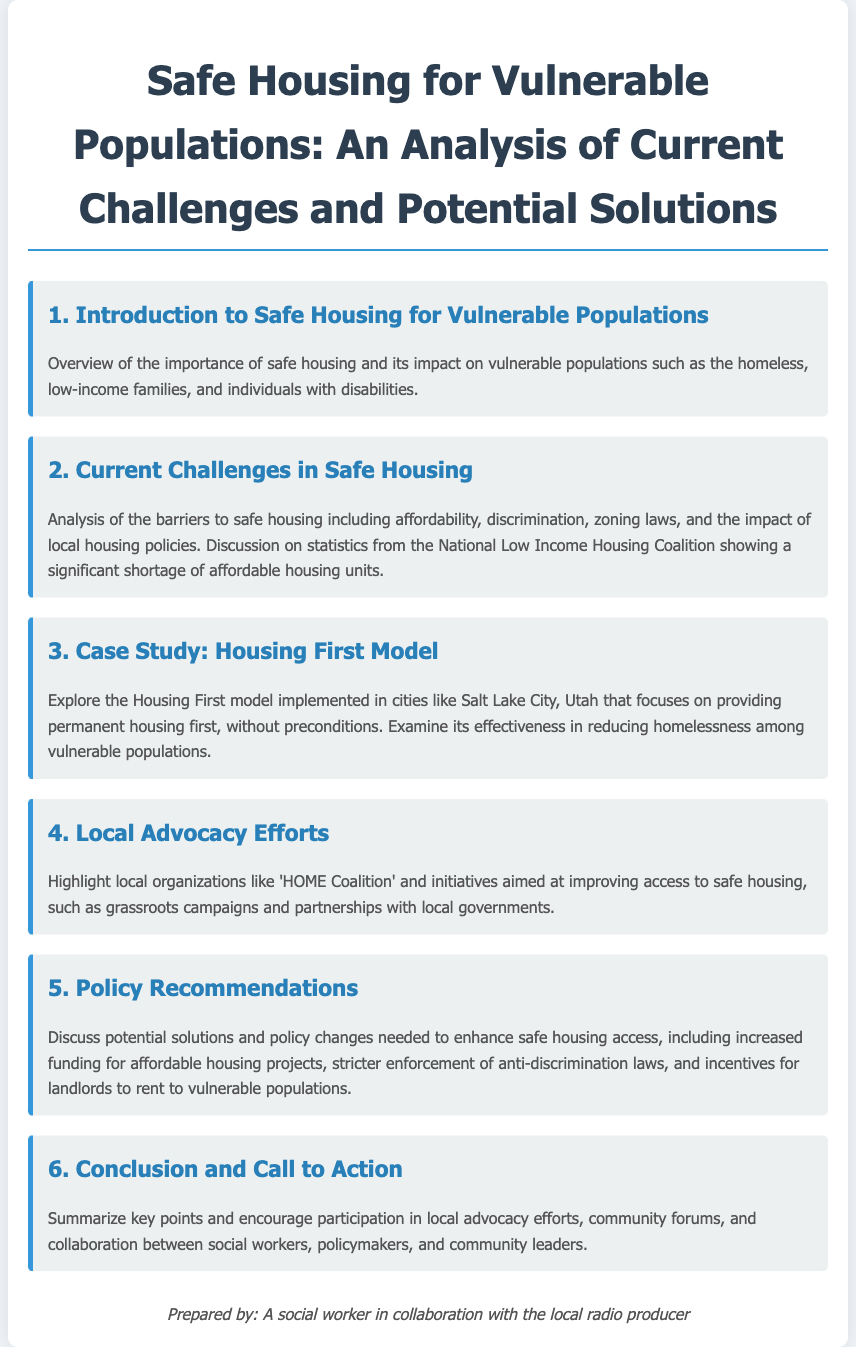What is the title of the agenda? The title of the agenda is featured prominently at the top of the document, clearly stating the focus of the analysis.
Answer: Safe Housing for Vulnerable Populations: An Analysis of Current Challenges and Potential Solutions What is the first agenda item? The first agenda item introduces the main topic and its importance, setting the stage for the discussion.
Answer: Introduction to Safe Housing for Vulnerable Populations What model is explored in the case study? The agenda item discusses a specific model implemented in various cities, which emphasizes the approach taken towards vulnerable populations.
Answer: Housing First Model Which local organization is highlighted for advocacy efforts? The document mentions specific advocacy groups that work towards improving housing access for vulnerable groups.
Answer: HOME Coalition What is a recommended policy change? The agenda outlines suggestions for enhancing access to safe housing, which includes revisions to current policy frameworks.
Answer: Increased funding for affordable housing projects How many agenda items are listed? The total number of items provides an overview of the various aspects covered in the document regarding safe housing.
Answer: Six What is the last agenda item? The final item summarizes the discussion and emphasizes the importance of community involvement and collaboration.
Answer: Conclusion and Call to Action What does the document discuss regarding zoning laws? The analysis includes obstacles to safe housing, which encompasses various legal and regulatory challenges communities face.
Answer: Barriers to safe housing including affordability, discrimination, zoning laws What city is mentioned in relation to the Housing First model? The document provides an example of a city that has successfully implemented the model as part of its strategy to combat homelessness.
Answer: Salt Lake City, Utah 